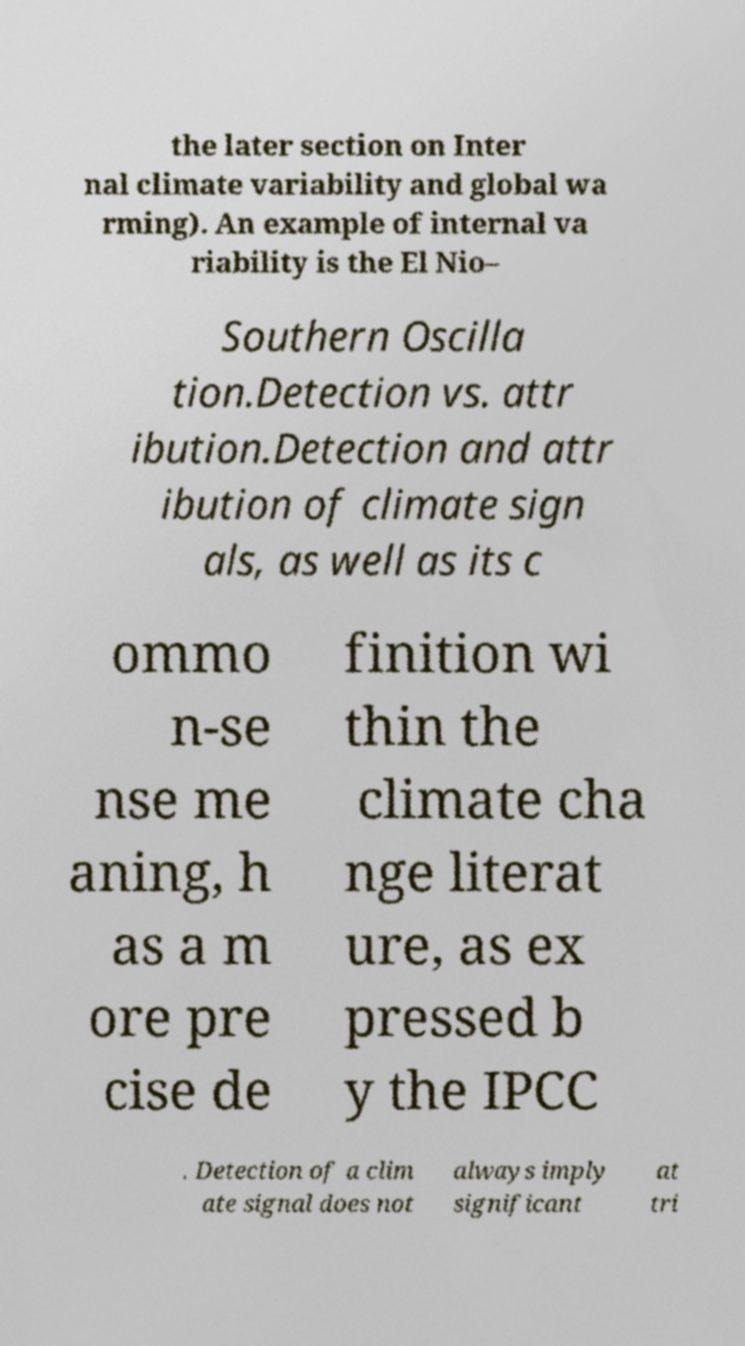Please read and relay the text visible in this image. What does it say? the later section on Inter nal climate variability and global wa rming). An example of internal va riability is the El Nio– Southern Oscilla tion.Detection vs. attr ibution.Detection and attr ibution of climate sign als, as well as its c ommo n-se nse me aning, h as a m ore pre cise de finition wi thin the climate cha nge literat ure, as ex pressed b y the IPCC . Detection of a clim ate signal does not always imply significant at tri 